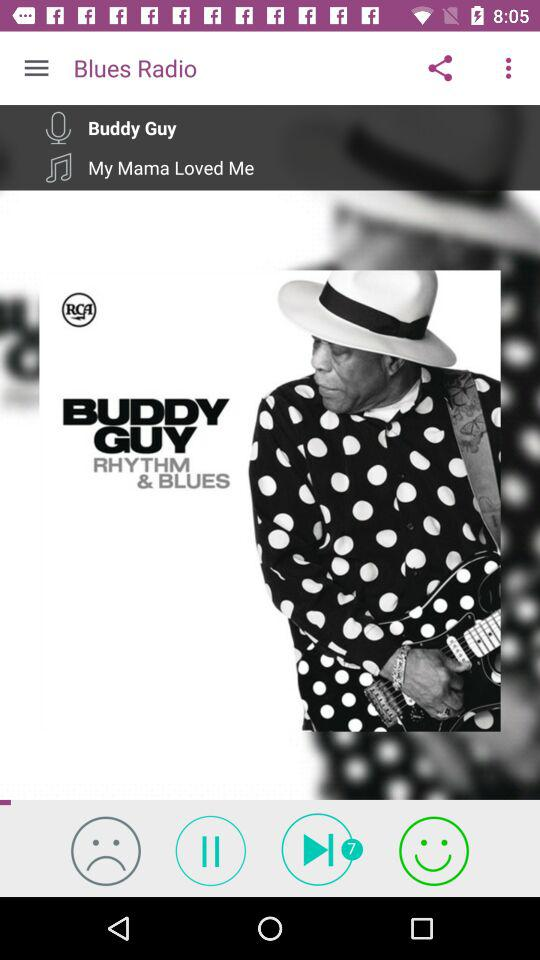How many unread notifications are in play? There are 7 unread notifications. 